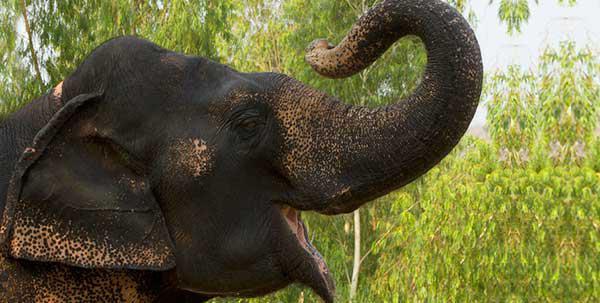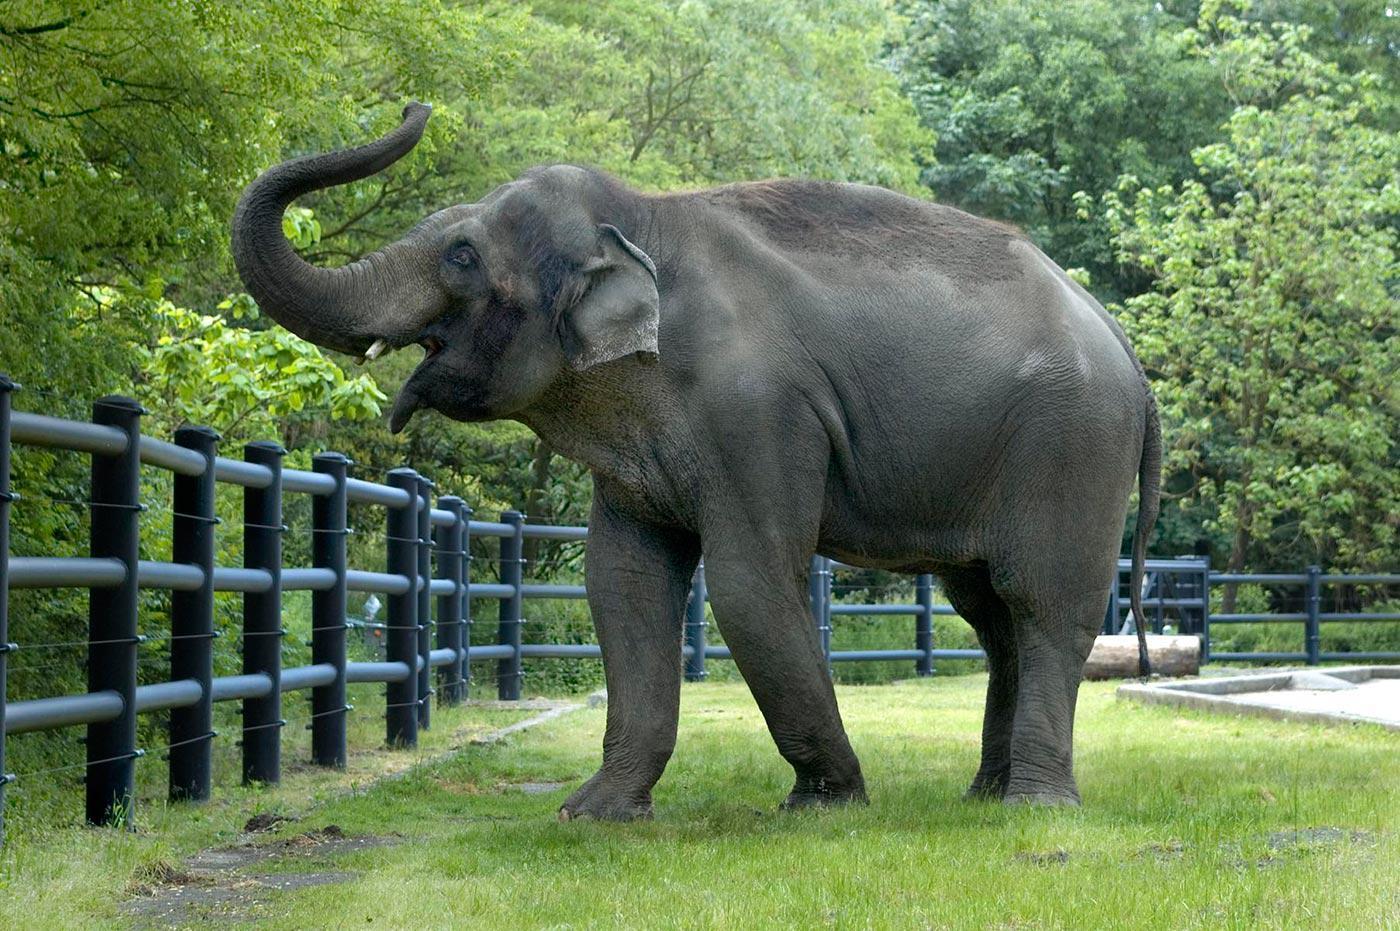The first image is the image on the left, the second image is the image on the right. For the images shown, is this caption "There is one elephant in each image." true? Answer yes or no. Yes. The first image is the image on the left, the second image is the image on the right. Evaluate the accuracy of this statement regarding the images: "There are more elephants in the image on the left.". Is it true? Answer yes or no. No. 